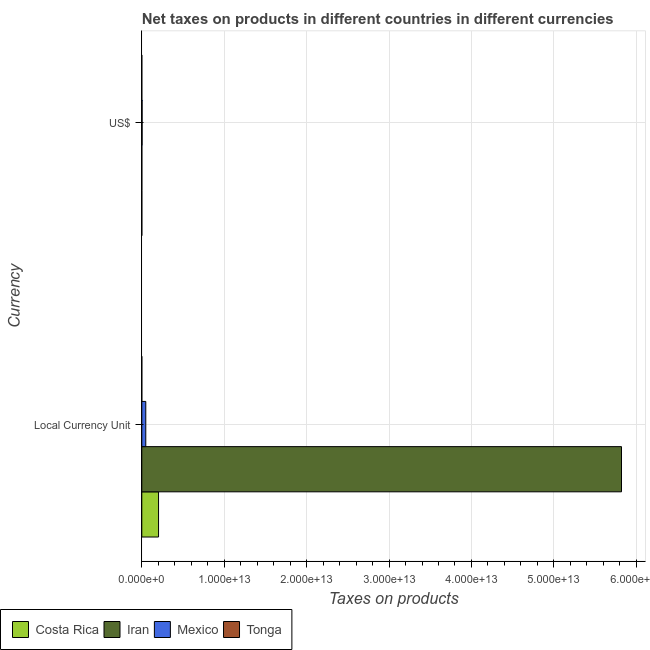How many different coloured bars are there?
Ensure brevity in your answer.  4. Are the number of bars on each tick of the Y-axis equal?
Give a very brief answer. Yes. How many bars are there on the 2nd tick from the top?
Offer a terse response. 4. How many bars are there on the 2nd tick from the bottom?
Provide a succinct answer. 4. What is the label of the 1st group of bars from the top?
Keep it short and to the point. US$. What is the net taxes in constant 2005 us$ in Tonga?
Keep it short and to the point. 1.01e+08. Across all countries, what is the maximum net taxes in constant 2005 us$?
Provide a short and direct response. 5.82e+13. Across all countries, what is the minimum net taxes in constant 2005 us$?
Offer a very short reply. 1.01e+08. In which country was the net taxes in us$ maximum?
Ensure brevity in your answer.  Mexico. In which country was the net taxes in us$ minimum?
Offer a terse response. Tonga. What is the total net taxes in us$ in the graph?
Provide a succinct answer. 4.55e+1. What is the difference between the net taxes in us$ in Mexico and that in Tonga?
Give a very brief answer. 3.66e+1. What is the difference between the net taxes in constant 2005 us$ in Iran and the net taxes in us$ in Costa Rica?
Your answer should be compact. 5.82e+13. What is the average net taxes in constant 2005 us$ per country?
Your answer should be very brief. 1.52e+13. What is the difference between the net taxes in constant 2005 us$ and net taxes in us$ in Tonga?
Your answer should be very brief. 4.23e+07. In how many countries, is the net taxes in us$ greater than 28000000000000 units?
Offer a very short reply. 0. What is the ratio of the net taxes in constant 2005 us$ in Mexico to that in Costa Rica?
Provide a short and direct response. 0.24. Is the net taxes in us$ in Mexico less than that in Costa Rica?
Provide a short and direct response. No. In how many countries, is the net taxes in us$ greater than the average net taxes in us$ taken over all countries?
Give a very brief answer. 1. What does the 1st bar from the top in Local Currency Unit represents?
Your response must be concise. Tonga. What does the 4th bar from the bottom in US$ represents?
Give a very brief answer. Tonga. Are all the bars in the graph horizontal?
Make the answer very short. Yes. What is the difference between two consecutive major ticks on the X-axis?
Offer a very short reply. 1.00e+13. Does the graph contain any zero values?
Offer a very short reply. No. Where does the legend appear in the graph?
Your answer should be compact. Bottom left. How many legend labels are there?
Your answer should be very brief. 4. What is the title of the graph?
Keep it short and to the point. Net taxes on products in different countries in different currencies. Does "Sao Tome and Principe" appear as one of the legend labels in the graph?
Your response must be concise. No. What is the label or title of the X-axis?
Ensure brevity in your answer.  Taxes on products. What is the label or title of the Y-axis?
Ensure brevity in your answer.  Currency. What is the Taxes on products in Costa Rica in Local Currency Unit?
Your response must be concise. 2.03e+12. What is the Taxes on products in Iran in Local Currency Unit?
Make the answer very short. 5.82e+13. What is the Taxes on products in Mexico in Local Currency Unit?
Your answer should be compact. 4.82e+11. What is the Taxes on products of Tonga in Local Currency Unit?
Your response must be concise. 1.01e+08. What is the Taxes on products of Costa Rica in US$?
Offer a very short reply. 4.04e+09. What is the Taxes on products of Iran in US$?
Ensure brevity in your answer.  4.78e+09. What is the Taxes on products of Mexico in US$?
Offer a terse response. 3.66e+1. What is the Taxes on products in Tonga in US$?
Make the answer very short. 5.88e+07. Across all Currency, what is the maximum Taxes on products of Costa Rica?
Provide a succinct answer. 2.03e+12. Across all Currency, what is the maximum Taxes on products of Iran?
Give a very brief answer. 5.82e+13. Across all Currency, what is the maximum Taxes on products in Mexico?
Your answer should be very brief. 4.82e+11. Across all Currency, what is the maximum Taxes on products of Tonga?
Give a very brief answer. 1.01e+08. Across all Currency, what is the minimum Taxes on products in Costa Rica?
Offer a terse response. 4.04e+09. Across all Currency, what is the minimum Taxes on products in Iran?
Ensure brevity in your answer.  4.78e+09. Across all Currency, what is the minimum Taxes on products of Mexico?
Your answer should be compact. 3.66e+1. Across all Currency, what is the minimum Taxes on products of Tonga?
Your answer should be compact. 5.88e+07. What is the total Taxes on products of Costa Rica in the graph?
Give a very brief answer. 2.04e+12. What is the total Taxes on products in Iran in the graph?
Your response must be concise. 5.82e+13. What is the total Taxes on products of Mexico in the graph?
Your response must be concise. 5.19e+11. What is the total Taxes on products of Tonga in the graph?
Provide a short and direct response. 1.60e+08. What is the difference between the Taxes on products in Costa Rica in Local Currency Unit and that in US$?
Your answer should be compact. 2.03e+12. What is the difference between the Taxes on products in Iran in Local Currency Unit and that in US$?
Provide a succinct answer. 5.82e+13. What is the difference between the Taxes on products of Mexico in Local Currency Unit and that in US$?
Offer a terse response. 4.46e+11. What is the difference between the Taxes on products of Tonga in Local Currency Unit and that in US$?
Offer a very short reply. 4.23e+07. What is the difference between the Taxes on products of Costa Rica in Local Currency Unit and the Taxes on products of Iran in US$?
Offer a very short reply. 2.03e+12. What is the difference between the Taxes on products in Costa Rica in Local Currency Unit and the Taxes on products in Mexico in US$?
Your answer should be compact. 1.99e+12. What is the difference between the Taxes on products of Costa Rica in Local Currency Unit and the Taxes on products of Tonga in US$?
Your answer should be compact. 2.03e+12. What is the difference between the Taxes on products in Iran in Local Currency Unit and the Taxes on products in Mexico in US$?
Make the answer very short. 5.82e+13. What is the difference between the Taxes on products in Iran in Local Currency Unit and the Taxes on products in Tonga in US$?
Offer a terse response. 5.82e+13. What is the difference between the Taxes on products of Mexico in Local Currency Unit and the Taxes on products of Tonga in US$?
Your response must be concise. 4.82e+11. What is the average Taxes on products of Costa Rica per Currency?
Your answer should be compact. 1.02e+12. What is the average Taxes on products in Iran per Currency?
Give a very brief answer. 2.91e+13. What is the average Taxes on products in Mexico per Currency?
Your response must be concise. 2.59e+11. What is the average Taxes on products in Tonga per Currency?
Offer a very short reply. 7.99e+07. What is the difference between the Taxes on products in Costa Rica and Taxes on products in Iran in Local Currency Unit?
Your answer should be very brief. -5.62e+13. What is the difference between the Taxes on products in Costa Rica and Taxes on products in Mexico in Local Currency Unit?
Your response must be concise. 1.55e+12. What is the difference between the Taxes on products in Costa Rica and Taxes on products in Tonga in Local Currency Unit?
Offer a very short reply. 2.03e+12. What is the difference between the Taxes on products in Iran and Taxes on products in Mexico in Local Currency Unit?
Your answer should be compact. 5.77e+13. What is the difference between the Taxes on products in Iran and Taxes on products in Tonga in Local Currency Unit?
Offer a very short reply. 5.82e+13. What is the difference between the Taxes on products in Mexico and Taxes on products in Tonga in Local Currency Unit?
Provide a short and direct response. 4.82e+11. What is the difference between the Taxes on products in Costa Rica and Taxes on products in Iran in US$?
Offer a terse response. -7.41e+08. What is the difference between the Taxes on products in Costa Rica and Taxes on products in Mexico in US$?
Your answer should be compact. -3.26e+1. What is the difference between the Taxes on products in Costa Rica and Taxes on products in Tonga in US$?
Keep it short and to the point. 3.98e+09. What is the difference between the Taxes on products in Iran and Taxes on products in Mexico in US$?
Your response must be concise. -3.18e+1. What is the difference between the Taxes on products in Iran and Taxes on products in Tonga in US$?
Ensure brevity in your answer.  4.72e+09. What is the difference between the Taxes on products of Mexico and Taxes on products of Tonga in US$?
Your answer should be very brief. 3.66e+1. What is the ratio of the Taxes on products of Costa Rica in Local Currency Unit to that in US$?
Ensure brevity in your answer.  502.9. What is the ratio of the Taxes on products of Iran in Local Currency Unit to that in US$?
Provide a succinct answer. 1.22e+04. What is the ratio of the Taxes on products of Mexico in Local Currency Unit to that in US$?
Provide a short and direct response. 13.17. What is the ratio of the Taxes on products of Tonga in Local Currency Unit to that in US$?
Your response must be concise. 1.72. What is the difference between the highest and the second highest Taxes on products in Costa Rica?
Offer a terse response. 2.03e+12. What is the difference between the highest and the second highest Taxes on products in Iran?
Keep it short and to the point. 5.82e+13. What is the difference between the highest and the second highest Taxes on products of Mexico?
Ensure brevity in your answer.  4.46e+11. What is the difference between the highest and the second highest Taxes on products in Tonga?
Make the answer very short. 4.23e+07. What is the difference between the highest and the lowest Taxes on products in Costa Rica?
Keep it short and to the point. 2.03e+12. What is the difference between the highest and the lowest Taxes on products in Iran?
Ensure brevity in your answer.  5.82e+13. What is the difference between the highest and the lowest Taxes on products in Mexico?
Give a very brief answer. 4.46e+11. What is the difference between the highest and the lowest Taxes on products of Tonga?
Make the answer very short. 4.23e+07. 